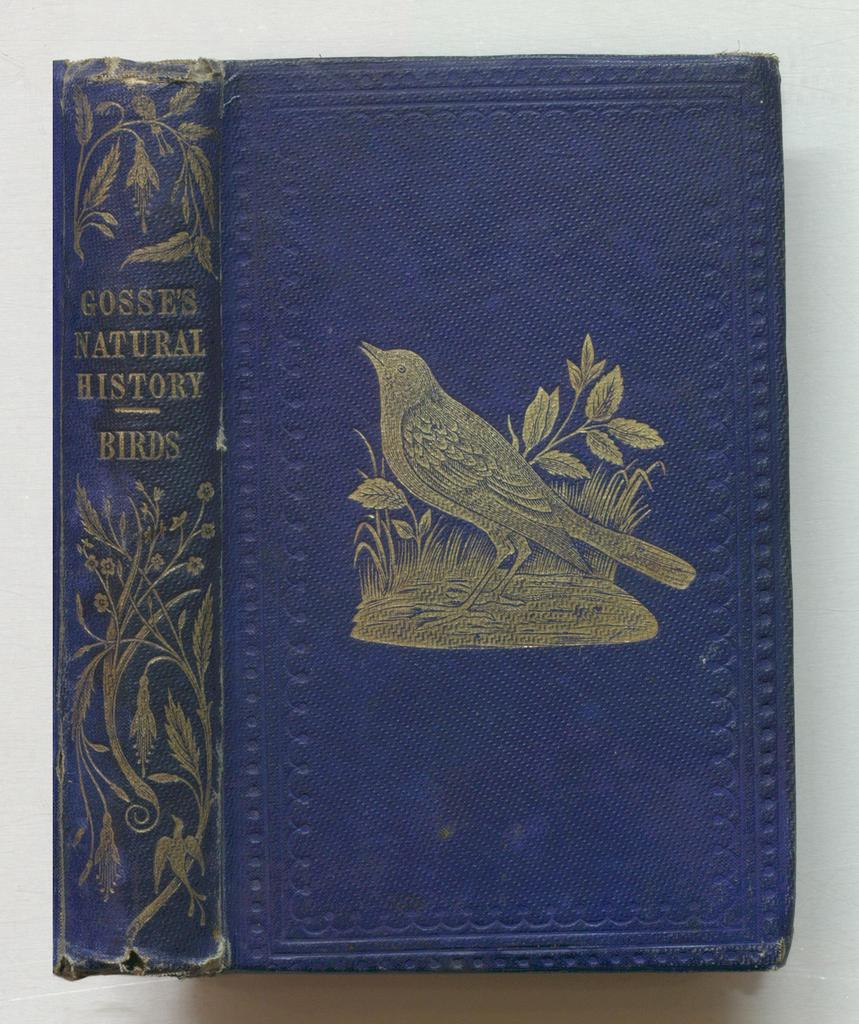<image>
Share a concise interpretation of the image provided. An older slightly frayed book titled Gosse's natural history Birds 